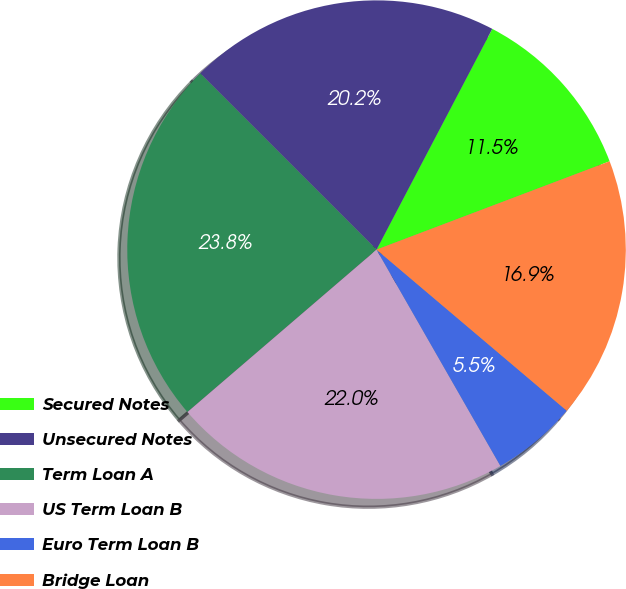Convert chart. <chart><loc_0><loc_0><loc_500><loc_500><pie_chart><fcel>Secured Notes<fcel>Unsecured Notes<fcel>Term Loan A<fcel>US Term Loan B<fcel>Euro Term Loan B<fcel>Bridge Loan<nl><fcel>11.55%<fcel>20.19%<fcel>23.79%<fcel>21.99%<fcel>5.54%<fcel>16.95%<nl></chart> 